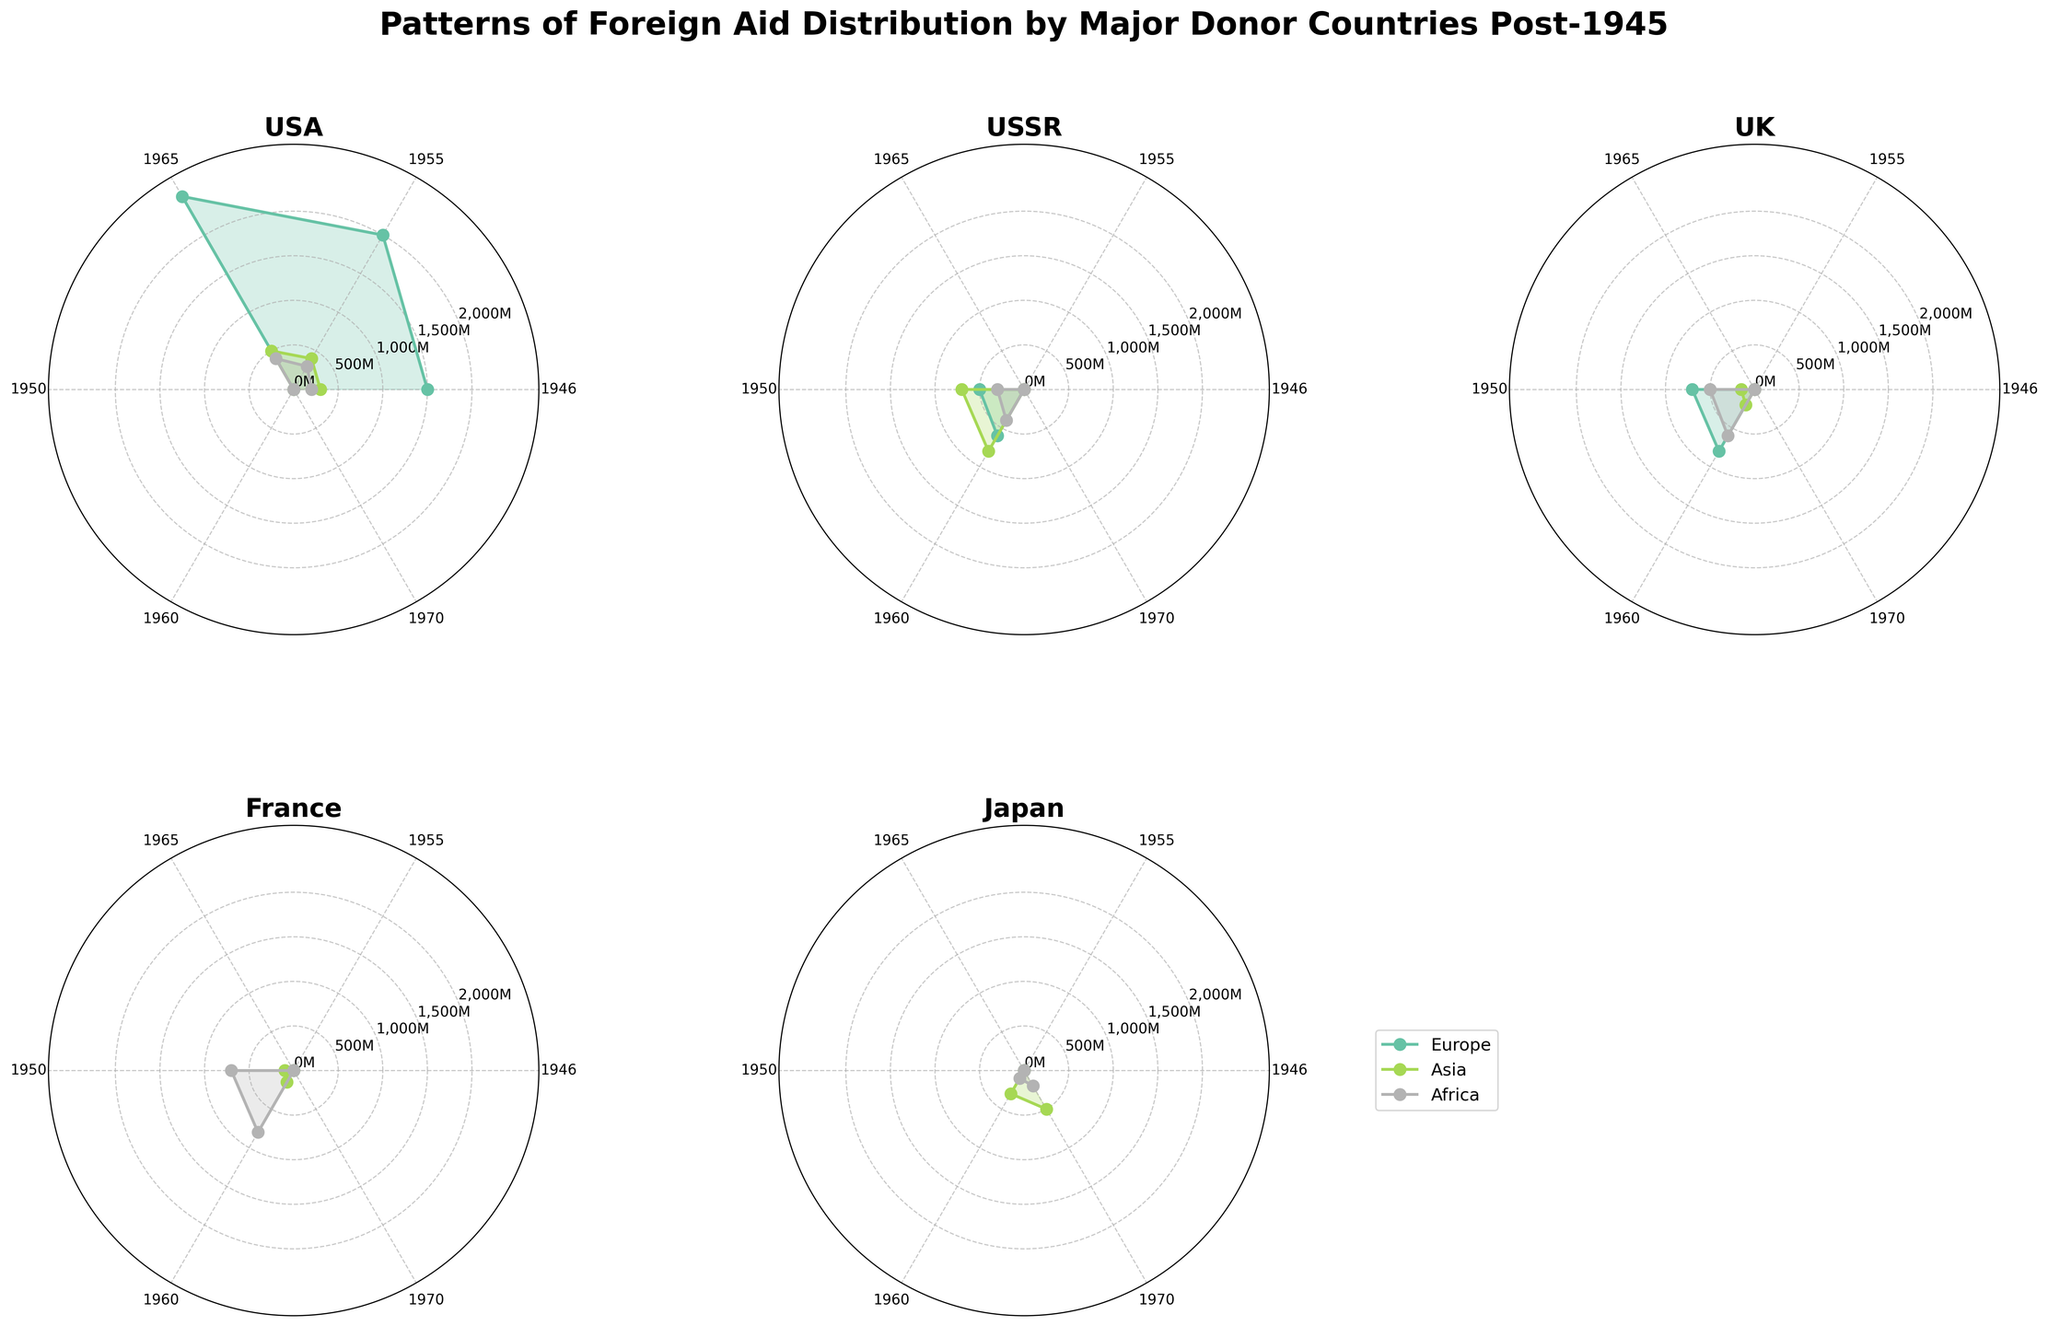What is the title of the figure? The title of the figure is typically positioned at the top of the chart. It is designed to provide an immediate understanding of what the visualized data is about. In this case, it is "Patterns of Foreign Aid Distribution by Major Donor Countries Post-1945", which indicates the topic of the figure.
Answer: Patterns of Foreign Aid Distribution by Major Donor Countries Post-1945 Which donor country provided the most aid to Europe in 1946? By examining the segments of the polar charts, particularly for the USA in 1946, we notice that it distributed the largest aid amount to Europe. The USA has the largest radial length in the Europe segment when comparing all donor countries in 1946.
Answer: USA How does the amount of foreign aid sent by the USA to Africa change from 1946 to 1965? By comparing the radial lengths of the USA's foreign aid to Africa in 1946, 1955, and 1965, we observe incremental increases: 200 in 1946, 300 in 1955, and 400 in 1965. This shows a steady upward trend.
Answer: It increases from 200 to 400 Which region consistently received the least foreign aid from the UK from 1950 to 1960? By examining the radial segments of the UK's subplot for 1950 and 1960, it is clear that Asia consistently has the shortest radial lengths, receiving the least aid compared to Europe and Africa.
Answer: Asia What was the total foreign aid given by the USSR to Asia in the 1950s and 1960s combined? Summing the foreign aid amounts for Asia from the USSR in 1950 (700) and 1960 (800), the total is 700 + 800 = 1500.
Answer: 1500 Compare and contrast the patterns of foreign aid distribution by the USA and USSR in the 1950s. Comparing the USA's and USSR's polar charts for the 1950s, the USA aids Europe significantly more than other regions, whereas the USSR provides more balanced aid with Asia receiving slightly more. Both countries aid Europe, Asia, and Africa, but their amounts and distributions differ.
Answer: USA focused more on Europe; USSR had a more balanced distribution What was the highest foreign aid amount offered by France and to which region? By examining the chart for France, the highest radial length is in the Africa segment in 1960, where France provided 800 in foreign aid.
Answer: 800 to Africa In which year did Japan start providing foreign aid to Africa? By looking at Japan's polar chart subplot, the first radial segment for Africa appears in 1960, indicating the year Japan started providing aid to Africa.
Answer: 1960 What trend can you observe regarding UK's foreign aid distribution to Africa between 1950 and 1960? By comparing the UK's polar charts for Africa in 1950 and 1960, there is a visible increase from 500 to 600, showing a growth trend in foreign aid to Africa.
Answer: Increasing trend 